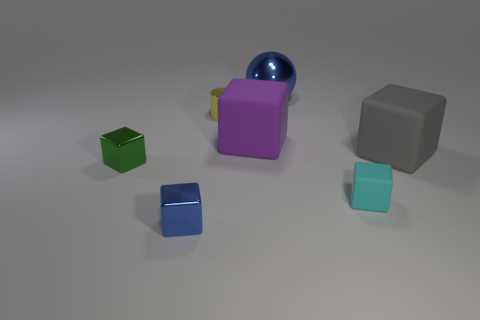There is a large rubber object that is left of the cyan matte thing; what color is it?
Give a very brief answer. Purple. Is there a green thing of the same shape as the small blue object?
Give a very brief answer. Yes. What is the material of the small cylinder?
Make the answer very short. Metal. There is a object that is on the left side of the sphere and on the right side of the tiny yellow metal object; what is its size?
Provide a short and direct response. Large. What is the material of the object that is the same color as the ball?
Keep it short and to the point. Metal. How many metal things are there?
Offer a terse response. 4. Is the number of yellow metal cylinders less than the number of large rubber blocks?
Ensure brevity in your answer.  Yes. What is the material of the blue cube that is the same size as the cyan matte object?
Keep it short and to the point. Metal. How many things are either blue matte objects or large blocks?
Offer a terse response. 2. How many things are right of the metallic cylinder and behind the small green thing?
Your answer should be very brief. 3. 